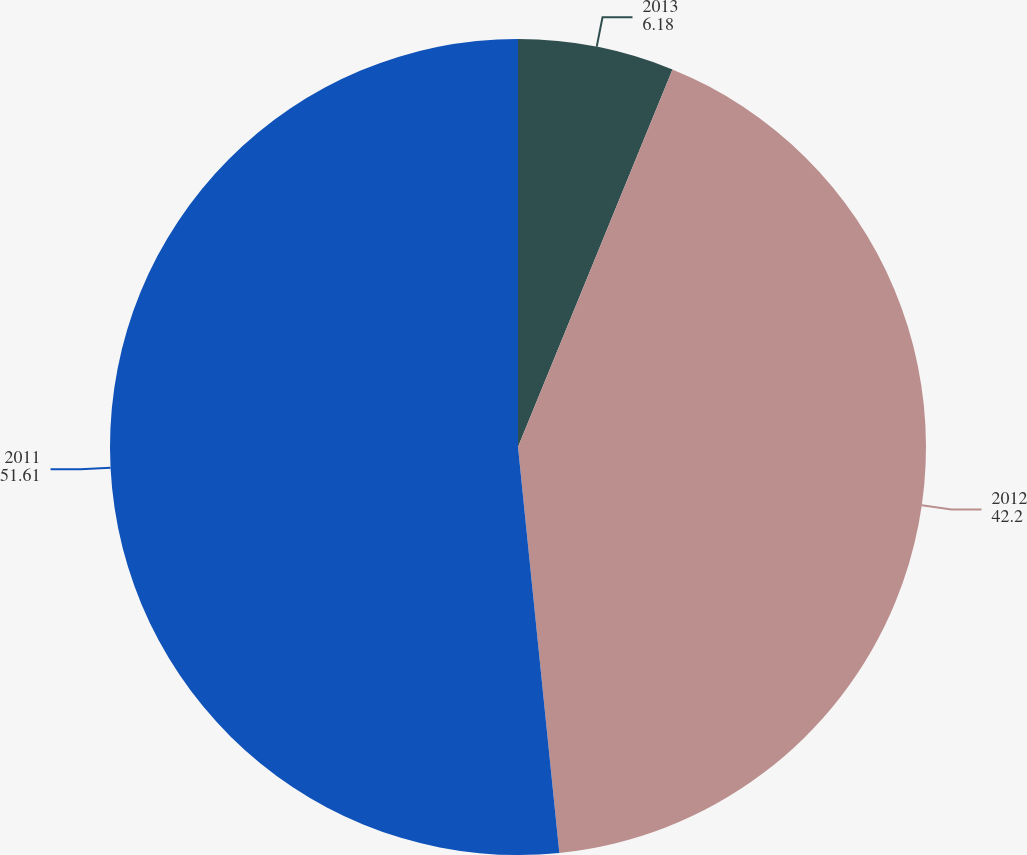Convert chart. <chart><loc_0><loc_0><loc_500><loc_500><pie_chart><fcel>2013<fcel>2012<fcel>2011<nl><fcel>6.18%<fcel>42.2%<fcel>51.61%<nl></chart> 